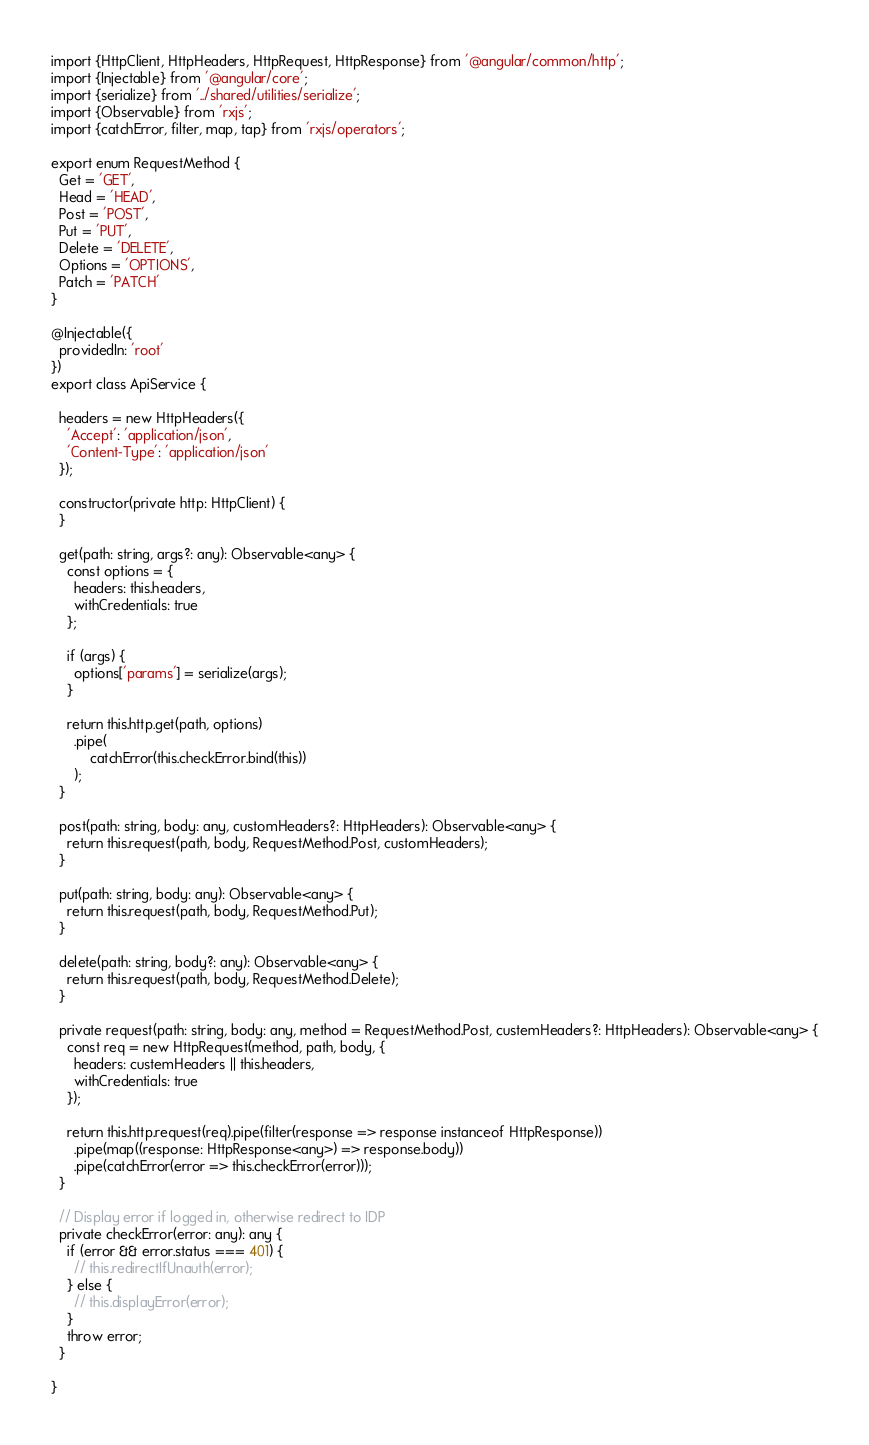Convert code to text. <code><loc_0><loc_0><loc_500><loc_500><_TypeScript_>import {HttpClient, HttpHeaders, HttpRequest, HttpResponse} from '@angular/common/http';
import {Injectable} from '@angular/core';
import {serialize} from '../shared/utilities/serialize';
import {Observable} from 'rxjs';
import {catchError, filter, map, tap} from 'rxjs/operators';

export enum RequestMethod {
  Get = 'GET',
  Head = 'HEAD',
  Post = 'POST',
  Put = 'PUT',
  Delete = 'DELETE',
  Options = 'OPTIONS',
  Patch = 'PATCH'
}

@Injectable({
  providedIn: 'root'
})
export class ApiService {

  headers = new HttpHeaders({
    'Accept': 'application/json',
    'Content-Type': 'application/json'
  });

  constructor(private http: HttpClient) {
  }

  get(path: string, args?: any): Observable<any> {
    const options = {
      headers: this.headers,
      withCredentials: true
    };

    if (args) {
      options['params'] = serialize(args);
    }

    return this.http.get(path, options)
      .pipe(
          catchError(this.checkError.bind(this))
      );
  }

  post(path: string, body: any, customHeaders?: HttpHeaders): Observable<any> {
    return this.request(path, body, RequestMethod.Post, customHeaders);
  }

  put(path: string, body: any): Observable<any> {
    return this.request(path, body, RequestMethod.Put);
  }

  delete(path: string, body?: any): Observable<any> {
    return this.request(path, body, RequestMethod.Delete);
  }

  private request(path: string, body: any, method = RequestMethod.Post, custemHeaders?: HttpHeaders): Observable<any> {
    const req = new HttpRequest(method, path, body, {
      headers: custemHeaders || this.headers,
      withCredentials: true
    });

    return this.http.request(req).pipe(filter(response => response instanceof HttpResponse))
      .pipe(map((response: HttpResponse<any>) => response.body))
      .pipe(catchError(error => this.checkError(error)));
  }

  // Display error if logged in, otherwise redirect to IDP
  private checkError(error: any): any {
    if (error && error.status === 401) {
      // this.redirectIfUnauth(error);
    } else {
      // this.displayError(error);
    }
    throw error;
  }

}
</code> 